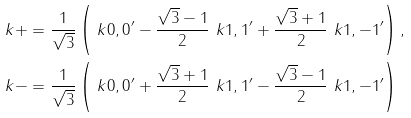<formula> <loc_0><loc_0><loc_500><loc_500>\ k { + } & = \frac { 1 } { \sqrt { 3 } } \left ( \ k { 0 , 0 } ^ { \prime } - \frac { \sqrt { 3 } - 1 } { 2 } \ k { 1 , 1 } ^ { \prime } + \frac { \sqrt { 3 } + 1 } { 2 } \ k { 1 , - 1 } ^ { \prime } \right ) , \\ \ k { - } & = \frac { 1 } { \sqrt { 3 } } \left ( \ k { 0 , 0 } ^ { \prime } + \frac { \sqrt { 3 } + 1 } { 2 } \ k { 1 , 1 } ^ { \prime } - \frac { \sqrt { 3 } - 1 } { 2 } \ k { 1 , - 1 } ^ { \prime } \right )</formula> 